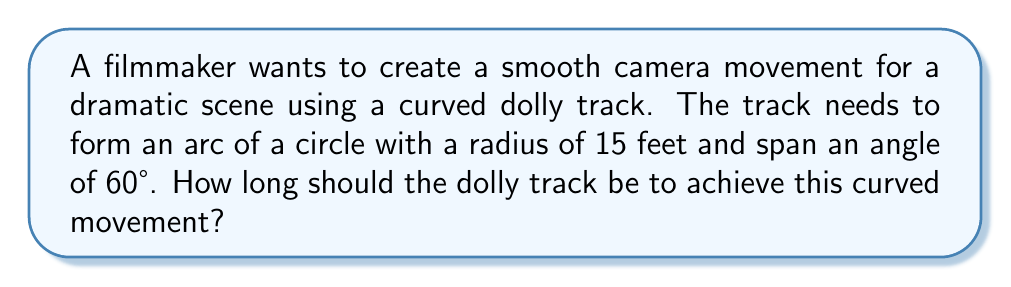Could you help me with this problem? To solve this problem, we need to use the formula for the length of an arc. In trigonometry, the length of an arc is given by:

$$s = r\theta$$

Where:
$s$ = length of the arc (what we're solving for)
$r$ = radius of the circle
$\theta$ = central angle in radians

We're given:
$r = 15$ feet
$\theta = 60°$

However, we need to convert the angle from degrees to radians:

$$\theta_{radians} = \theta_{degrees} \cdot \frac{\pi}{180°}$$

$$\theta_{radians} = 60° \cdot \frac{\pi}{180°} = \frac{\pi}{3}$$

Now we can plug these values into our arc length formula:

$$s = r\theta$$
$$s = 15 \cdot \frac{\pi}{3}$$
$$s = 5\pi$$

Therefore, the length of the dolly track should be $5\pi$ feet.

To convert this to a decimal approximation:
$$s \approx 15.71 \text{ feet}$$
Answer: The dolly track should be $5\pi$ feet long (approximately 15.71 feet). 